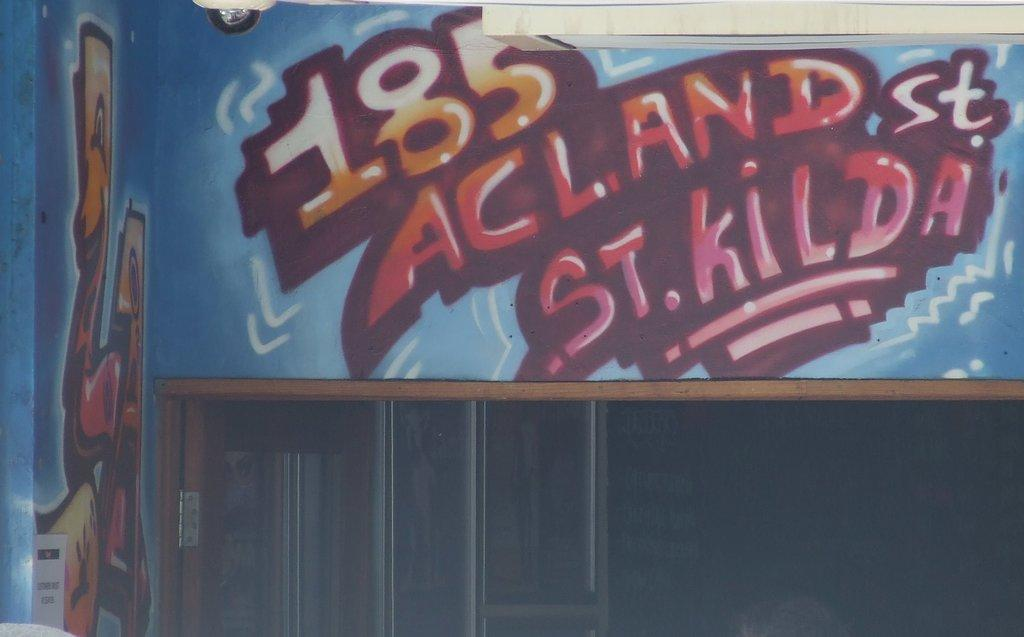<image>
Relay a brief, clear account of the picture shown. a painting with the numbers 185 at the top of it 